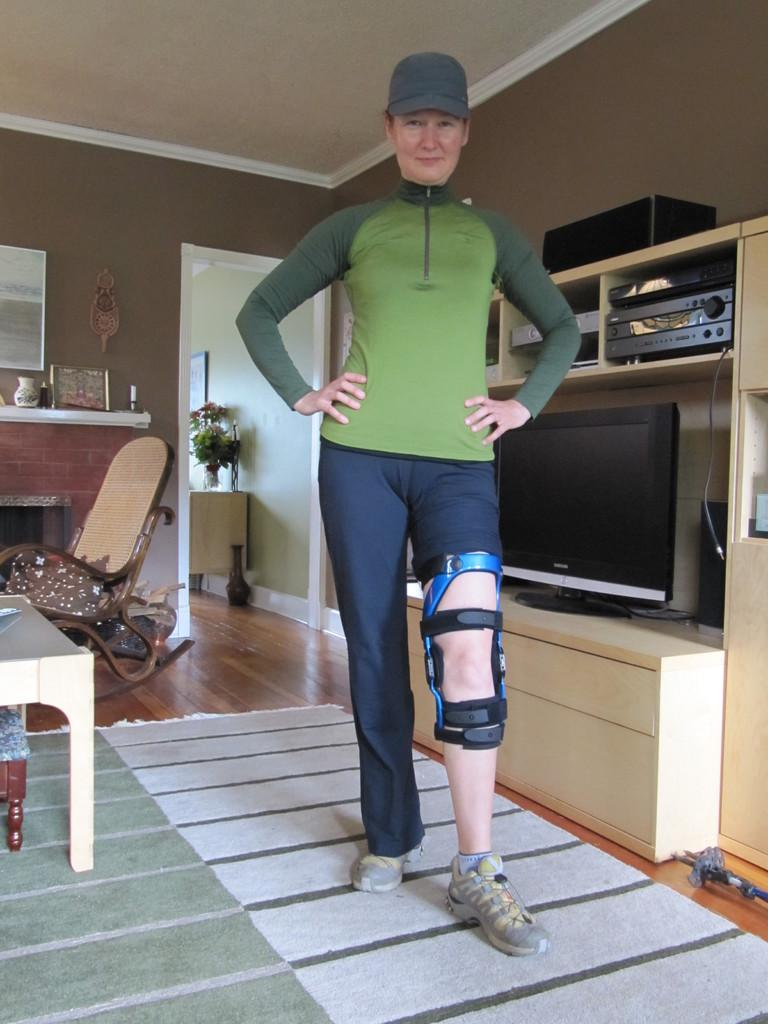What is the main subject of the image? There is a woman standing in the image. What is the woman wearing or holding that is attached to her leg? The woman has a belt tightened to one of her legs. What electronic device is present in the image? There is a television in the image. What type of entertainment system is visible in the image? There is a home theater in the image. What type of furniture is present in the image? There is a chair in the image. What type of powder can be seen falling from the ceiling in the image? There is no powder falling from the ceiling in the image. What type of truck is parked outside the window in the image? There is no truck visible in the image. 